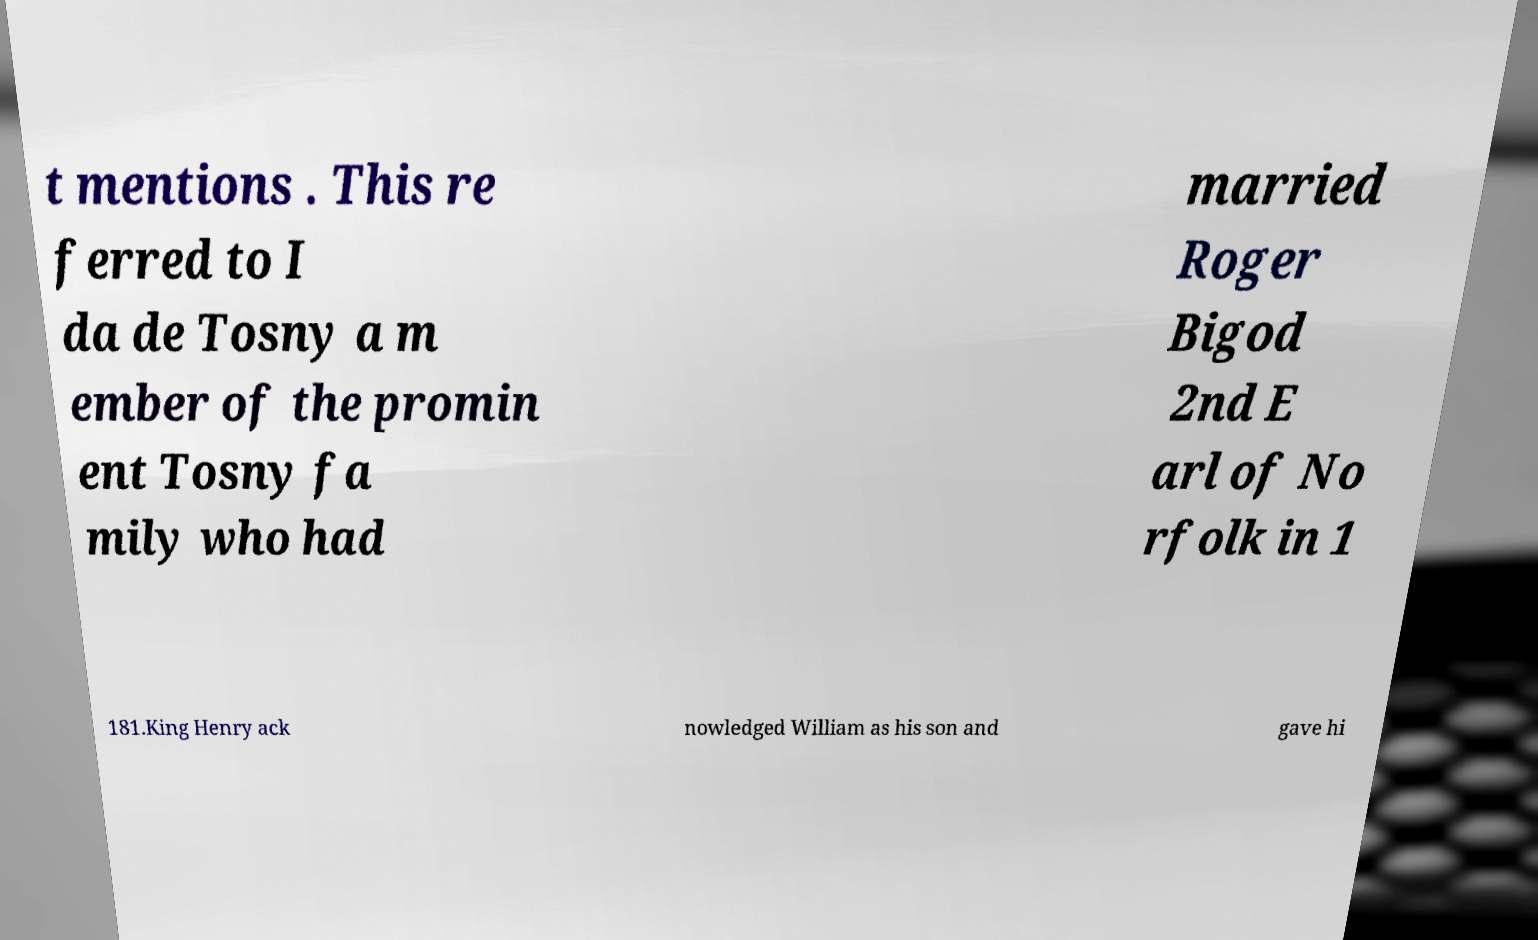Can you read and provide the text displayed in the image?This photo seems to have some interesting text. Can you extract and type it out for me? t mentions . This re ferred to I da de Tosny a m ember of the promin ent Tosny fa mily who had married Roger Bigod 2nd E arl of No rfolk in 1 181.King Henry ack nowledged William as his son and gave hi 